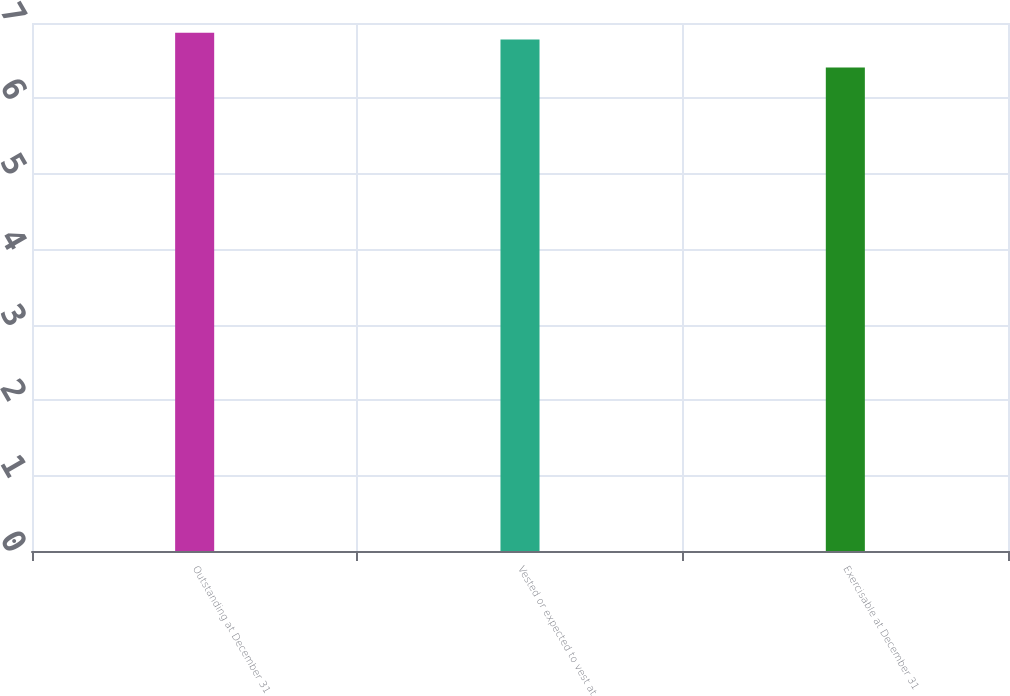<chart> <loc_0><loc_0><loc_500><loc_500><bar_chart><fcel>Outstanding at December 31<fcel>Vested or expected to vest at<fcel>Exercisable at December 31<nl><fcel>6.87<fcel>6.78<fcel>6.41<nl></chart> 